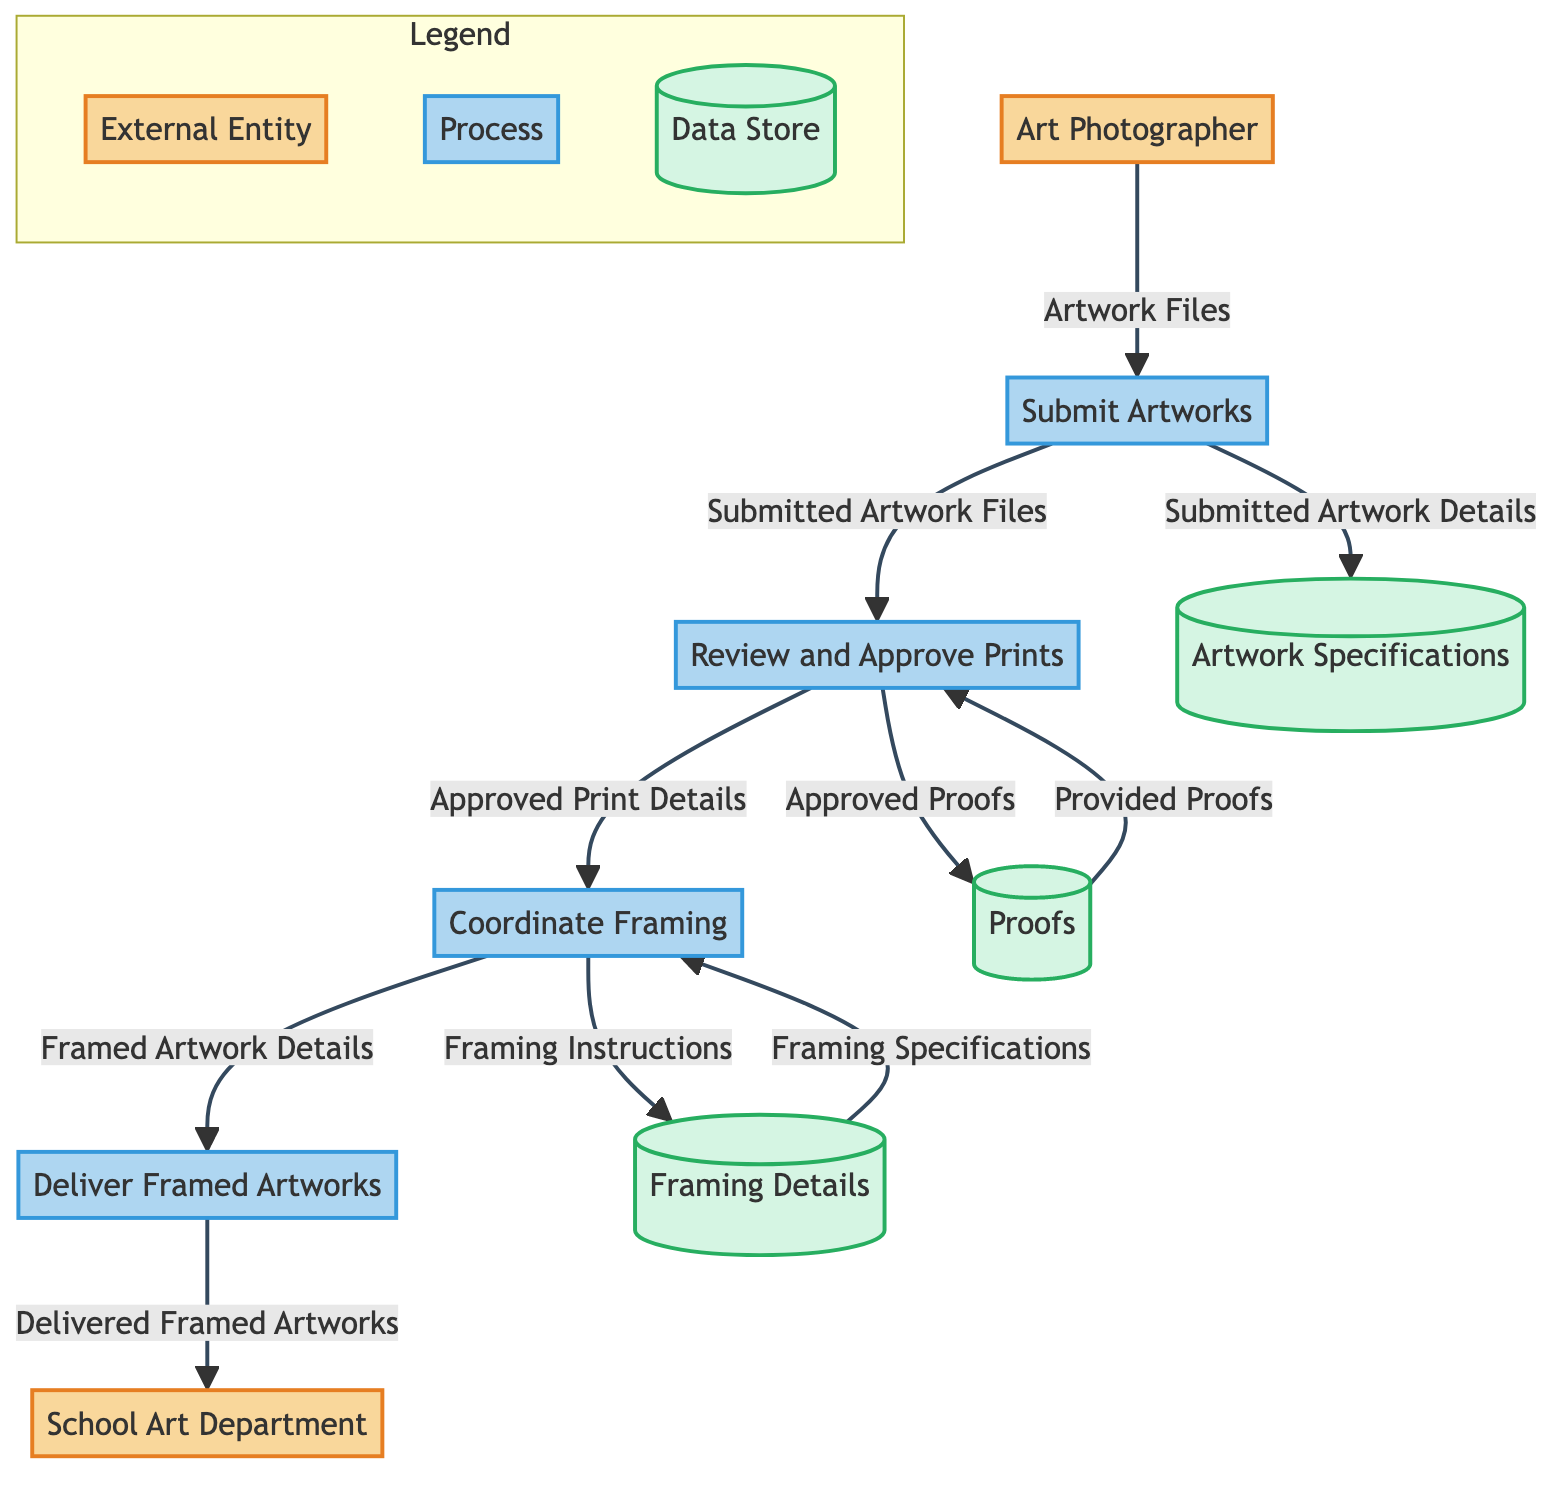What is the first process in the flow? The first process in the flow is identified as "Submit Artworks," which is the initial step taken by the Art Photographer to start the coordination with printing and framing services for the artworks.
Answer: Submit Artworks How many external entities are there in the diagram? The diagram includes a total of two external entities: the Art Photographer and the School Art Department, which are clearly labeled in the external entities section.
Answer: 2 What data does the Art Photographer send to the Submit Artworks process? The Art Photographer sends "Artwork Files" to the Submit Artworks process, as indicated by the arrow labeled with that data flow in the diagram.
Answer: Artwork Files Which process comes after Reviewing and Approving Prints? After the "Review and Approve Prints" process, the next process is "Coordinate Framing," as shown by the directional flow from the review process to the framing process.
Answer: Coordinate Framing What is the last process that delivers completed works? The last process in the flow that delivers the completed or final works to the School Art Department is "Deliver Framed Artworks," denoted as the endpoint in the diagram flow.
Answer: Deliver Framed Artworks What data flows from Coordinate Framing to Deliver Framed Artworks? The data that flows from "Coordinate Framing" to "Deliver Framed Artworks" is "Framed Artwork Details," which is essential for the final delivery step.
Answer: Framed Artwork Details How many data stores are present in the diagram? There are three data stores mentioned in the diagram: Artwork Specifications, Proofs, and Framing Details, which serve different purposes in the process flow.
Answer: 3 What type of information does the Artwork Specifications store hold? The Artwork Specifications store holds information about the size, type, and style of artworks, which is necessary for the subsequent processing steps.
Answer: Size, type, and style of artworks What is the main task of the Review and Approve Prints process? The main task of the "Review and Approve Prints" process is to allow the Art Photographer to evaluate and approve the proofs provided by the printing service, ensuring the quality of the prints.
Answer: Evaluate and approve proofs What data is sent from Proofs to Review and Approve Prints? The data sent from "Proofs" to "Review and Approve Prints" is labeled as "Provided Proofs," indicating the proofs received from the printing service for review.
Answer: Provided Proofs 